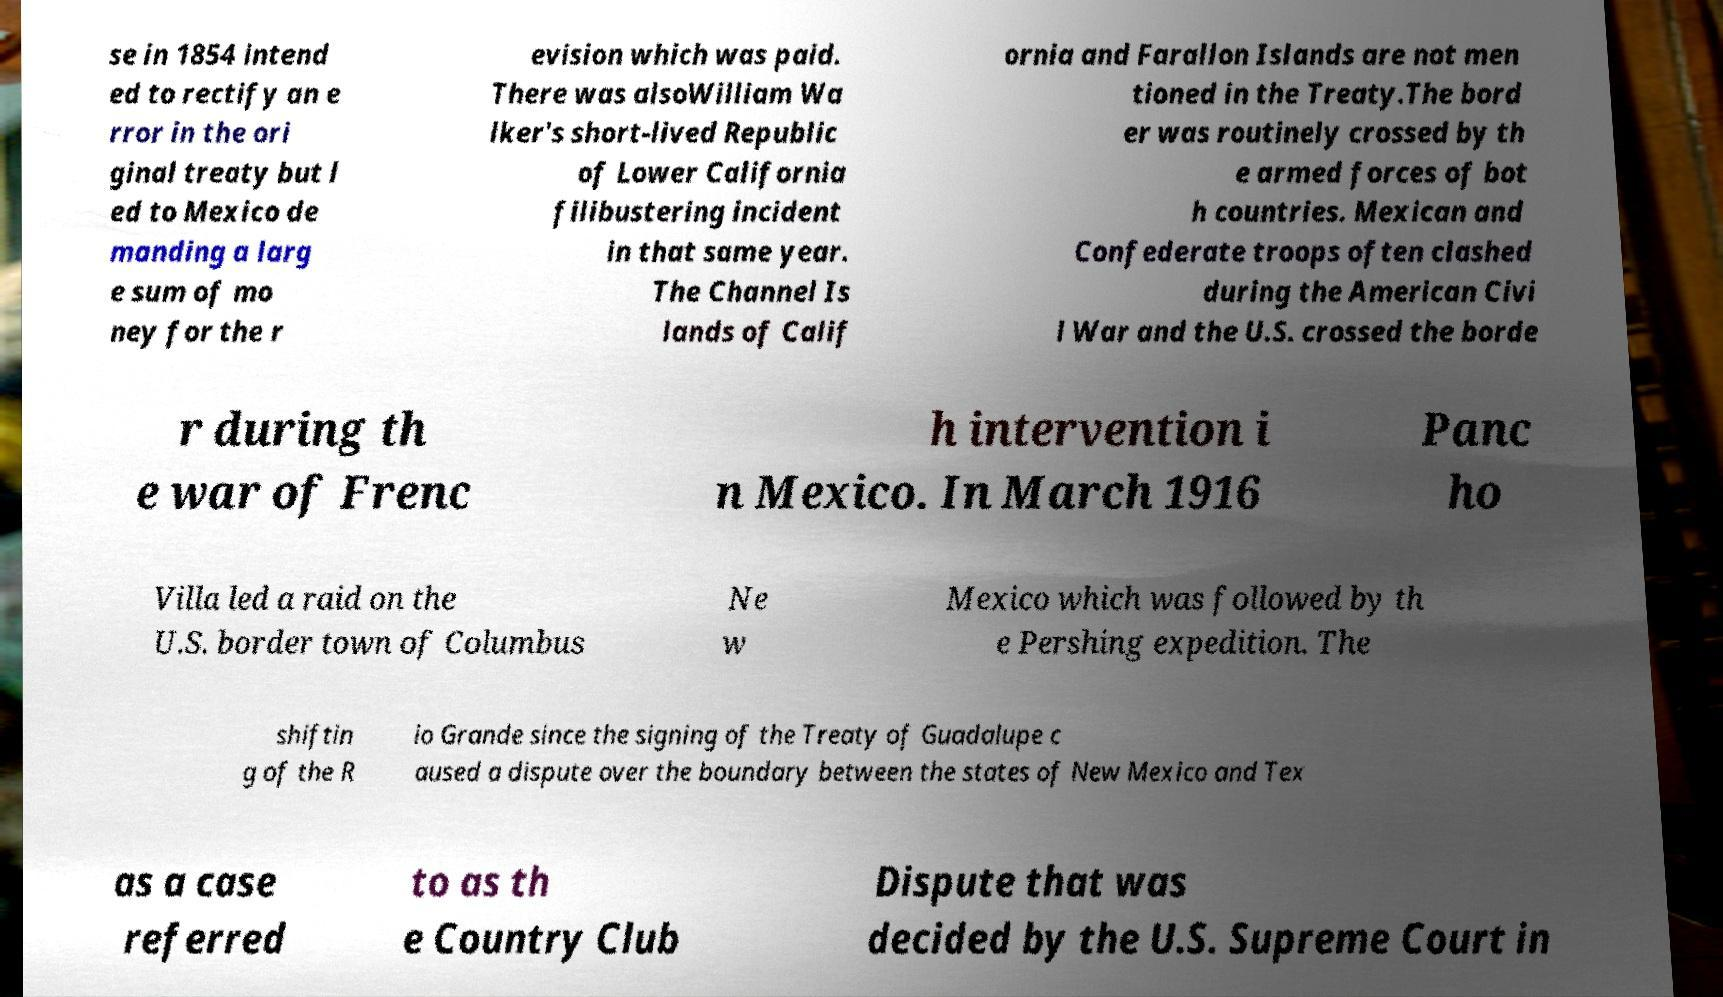There's text embedded in this image that I need extracted. Can you transcribe it verbatim? se in 1854 intend ed to rectify an e rror in the ori ginal treaty but l ed to Mexico de manding a larg e sum of mo ney for the r evision which was paid. There was alsoWilliam Wa lker's short-lived Republic of Lower California filibustering incident in that same year. The Channel Is lands of Calif ornia and Farallon Islands are not men tioned in the Treaty.The bord er was routinely crossed by th e armed forces of bot h countries. Mexican and Confederate troops often clashed during the American Civi l War and the U.S. crossed the borde r during th e war of Frenc h intervention i n Mexico. In March 1916 Panc ho Villa led a raid on the U.S. border town of Columbus Ne w Mexico which was followed by th e Pershing expedition. The shiftin g of the R io Grande since the signing of the Treaty of Guadalupe c aused a dispute over the boundary between the states of New Mexico and Tex as a case referred to as th e Country Club Dispute that was decided by the U.S. Supreme Court in 